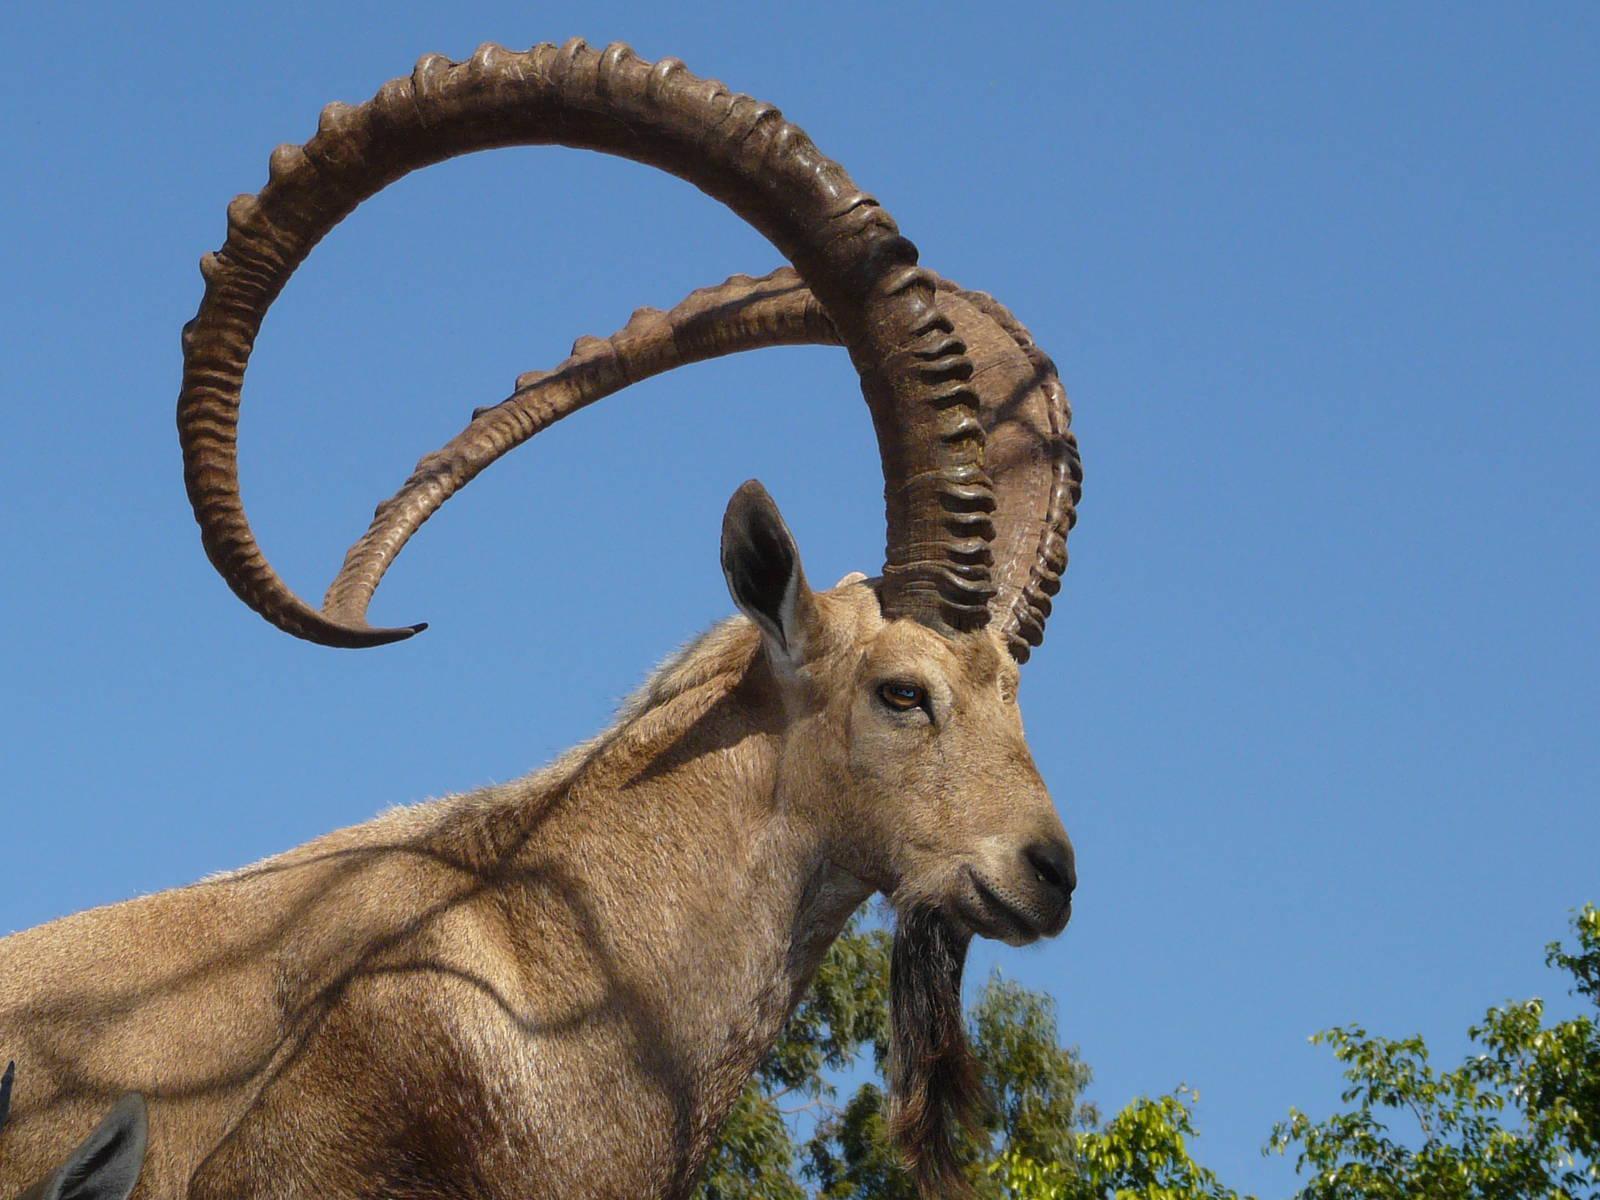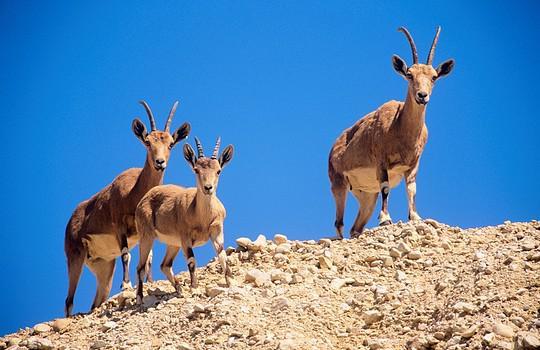The first image is the image on the left, the second image is the image on the right. Evaluate the accuracy of this statement regarding the images: "One big horn sheep is facing left.". Is it true? Answer yes or no. No. The first image is the image on the left, the second image is the image on the right. Evaluate the accuracy of this statement regarding the images: "Exactly one animal is facing to the left.". Is it true? Answer yes or no. No. The first image is the image on the left, the second image is the image on the right. Examine the images to the left and right. Is the description "The images show a single horned animal, and they face in different [left or right] directions." accurate? Answer yes or no. No. The first image is the image on the left, the second image is the image on the right. Assess this claim about the two images: "There are at least three mountain goats.". Correct or not? Answer yes or no. Yes. 